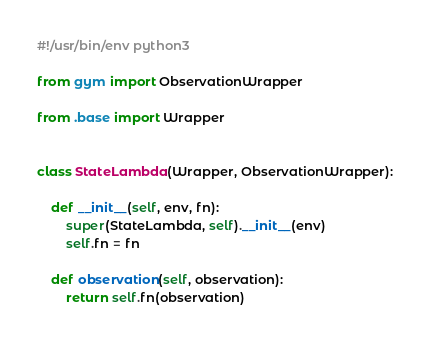<code> <loc_0><loc_0><loc_500><loc_500><_Python_>#!/usr/bin/env python3

from gym import ObservationWrapper

from .base import Wrapper


class StateLambda(Wrapper, ObservationWrapper):

    def __init__(self, env, fn):
        super(StateLambda, self).__init__(env)
        self.fn = fn

    def observation(self, observation):
        return self.fn(observation)
</code> 